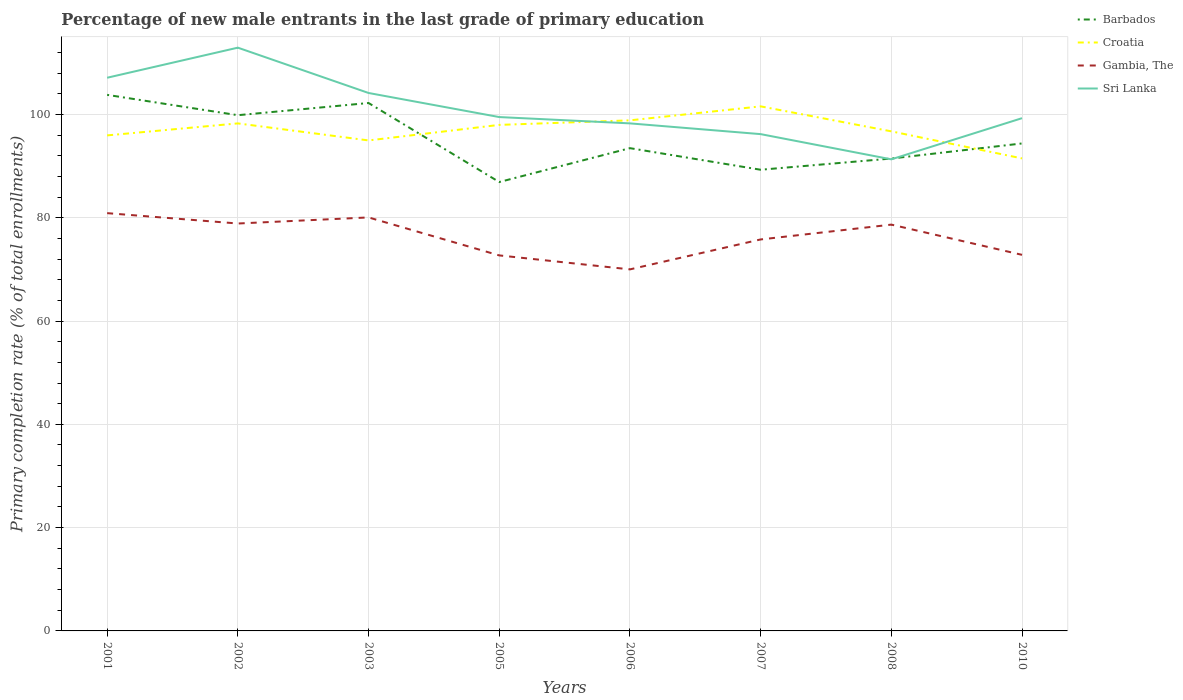How many different coloured lines are there?
Offer a very short reply. 4. Across all years, what is the maximum percentage of new male entrants in Gambia, The?
Your answer should be very brief. 70.01. What is the total percentage of new male entrants in Sri Lanka in the graph?
Provide a succinct answer. 8.18. What is the difference between the highest and the second highest percentage of new male entrants in Barbados?
Your answer should be very brief. 16.88. How many lines are there?
Ensure brevity in your answer.  4. How many years are there in the graph?
Provide a succinct answer. 8. What is the difference between two consecutive major ticks on the Y-axis?
Offer a terse response. 20. Does the graph contain any zero values?
Offer a terse response. No. Does the graph contain grids?
Offer a very short reply. Yes. How many legend labels are there?
Provide a succinct answer. 4. How are the legend labels stacked?
Offer a terse response. Vertical. What is the title of the graph?
Make the answer very short. Percentage of new male entrants in the last grade of primary education. What is the label or title of the Y-axis?
Your answer should be compact. Primary completion rate (% of total enrollments). What is the Primary completion rate (% of total enrollments) of Barbados in 2001?
Provide a short and direct response. 103.8. What is the Primary completion rate (% of total enrollments) of Croatia in 2001?
Your answer should be compact. 95.95. What is the Primary completion rate (% of total enrollments) of Gambia, The in 2001?
Give a very brief answer. 80.89. What is the Primary completion rate (% of total enrollments) in Sri Lanka in 2001?
Your answer should be very brief. 107.11. What is the Primary completion rate (% of total enrollments) in Barbados in 2002?
Give a very brief answer. 99.86. What is the Primary completion rate (% of total enrollments) in Croatia in 2002?
Provide a short and direct response. 98.27. What is the Primary completion rate (% of total enrollments) in Gambia, The in 2002?
Offer a very short reply. 78.89. What is the Primary completion rate (% of total enrollments) in Sri Lanka in 2002?
Offer a very short reply. 112.94. What is the Primary completion rate (% of total enrollments) of Barbados in 2003?
Ensure brevity in your answer.  102.22. What is the Primary completion rate (% of total enrollments) of Croatia in 2003?
Give a very brief answer. 94.97. What is the Primary completion rate (% of total enrollments) in Gambia, The in 2003?
Provide a short and direct response. 80.06. What is the Primary completion rate (% of total enrollments) of Sri Lanka in 2003?
Offer a terse response. 104.16. What is the Primary completion rate (% of total enrollments) in Barbados in 2005?
Make the answer very short. 86.92. What is the Primary completion rate (% of total enrollments) of Croatia in 2005?
Your answer should be compact. 97.98. What is the Primary completion rate (% of total enrollments) in Gambia, The in 2005?
Keep it short and to the point. 72.71. What is the Primary completion rate (% of total enrollments) in Sri Lanka in 2005?
Your answer should be very brief. 99.5. What is the Primary completion rate (% of total enrollments) in Barbados in 2006?
Your answer should be compact. 93.48. What is the Primary completion rate (% of total enrollments) of Croatia in 2006?
Provide a succinct answer. 98.86. What is the Primary completion rate (% of total enrollments) of Gambia, The in 2006?
Give a very brief answer. 70.01. What is the Primary completion rate (% of total enrollments) in Sri Lanka in 2006?
Make the answer very short. 98.27. What is the Primary completion rate (% of total enrollments) of Barbados in 2007?
Offer a terse response. 89.3. What is the Primary completion rate (% of total enrollments) of Croatia in 2007?
Your answer should be compact. 101.57. What is the Primary completion rate (% of total enrollments) of Gambia, The in 2007?
Your answer should be very brief. 75.8. What is the Primary completion rate (% of total enrollments) in Sri Lanka in 2007?
Give a very brief answer. 96.19. What is the Primary completion rate (% of total enrollments) of Barbados in 2008?
Offer a terse response. 91.47. What is the Primary completion rate (% of total enrollments) in Croatia in 2008?
Offer a very short reply. 96.73. What is the Primary completion rate (% of total enrollments) in Gambia, The in 2008?
Offer a terse response. 78.67. What is the Primary completion rate (% of total enrollments) of Sri Lanka in 2008?
Provide a short and direct response. 91.31. What is the Primary completion rate (% of total enrollments) in Barbados in 2010?
Make the answer very short. 94.39. What is the Primary completion rate (% of total enrollments) of Croatia in 2010?
Make the answer very short. 91.49. What is the Primary completion rate (% of total enrollments) in Gambia, The in 2010?
Give a very brief answer. 72.82. What is the Primary completion rate (% of total enrollments) in Sri Lanka in 2010?
Ensure brevity in your answer.  99.28. Across all years, what is the maximum Primary completion rate (% of total enrollments) of Barbados?
Provide a succinct answer. 103.8. Across all years, what is the maximum Primary completion rate (% of total enrollments) of Croatia?
Your answer should be very brief. 101.57. Across all years, what is the maximum Primary completion rate (% of total enrollments) of Gambia, The?
Keep it short and to the point. 80.89. Across all years, what is the maximum Primary completion rate (% of total enrollments) in Sri Lanka?
Offer a very short reply. 112.94. Across all years, what is the minimum Primary completion rate (% of total enrollments) of Barbados?
Provide a short and direct response. 86.92. Across all years, what is the minimum Primary completion rate (% of total enrollments) of Croatia?
Provide a succinct answer. 91.49. Across all years, what is the minimum Primary completion rate (% of total enrollments) of Gambia, The?
Provide a succinct answer. 70.01. Across all years, what is the minimum Primary completion rate (% of total enrollments) of Sri Lanka?
Give a very brief answer. 91.31. What is the total Primary completion rate (% of total enrollments) of Barbados in the graph?
Make the answer very short. 761.42. What is the total Primary completion rate (% of total enrollments) of Croatia in the graph?
Provide a short and direct response. 775.83. What is the total Primary completion rate (% of total enrollments) of Gambia, The in the graph?
Your answer should be compact. 609.85. What is the total Primary completion rate (% of total enrollments) in Sri Lanka in the graph?
Give a very brief answer. 808.77. What is the difference between the Primary completion rate (% of total enrollments) in Barbados in 2001 and that in 2002?
Provide a short and direct response. 3.94. What is the difference between the Primary completion rate (% of total enrollments) of Croatia in 2001 and that in 2002?
Provide a succinct answer. -2.32. What is the difference between the Primary completion rate (% of total enrollments) in Gambia, The in 2001 and that in 2002?
Your answer should be very brief. 2.01. What is the difference between the Primary completion rate (% of total enrollments) of Sri Lanka in 2001 and that in 2002?
Your answer should be very brief. -5.82. What is the difference between the Primary completion rate (% of total enrollments) of Barbados in 2001 and that in 2003?
Make the answer very short. 1.58. What is the difference between the Primary completion rate (% of total enrollments) in Croatia in 2001 and that in 2003?
Your response must be concise. 0.98. What is the difference between the Primary completion rate (% of total enrollments) of Gambia, The in 2001 and that in 2003?
Your response must be concise. 0.83. What is the difference between the Primary completion rate (% of total enrollments) in Sri Lanka in 2001 and that in 2003?
Keep it short and to the point. 2.95. What is the difference between the Primary completion rate (% of total enrollments) of Barbados in 2001 and that in 2005?
Make the answer very short. 16.88. What is the difference between the Primary completion rate (% of total enrollments) of Croatia in 2001 and that in 2005?
Your answer should be compact. -2.03. What is the difference between the Primary completion rate (% of total enrollments) in Gambia, The in 2001 and that in 2005?
Your answer should be very brief. 8.18. What is the difference between the Primary completion rate (% of total enrollments) of Sri Lanka in 2001 and that in 2005?
Make the answer very short. 7.61. What is the difference between the Primary completion rate (% of total enrollments) of Barbados in 2001 and that in 2006?
Your response must be concise. 10.32. What is the difference between the Primary completion rate (% of total enrollments) of Croatia in 2001 and that in 2006?
Offer a terse response. -2.92. What is the difference between the Primary completion rate (% of total enrollments) in Gambia, The in 2001 and that in 2006?
Give a very brief answer. 10.89. What is the difference between the Primary completion rate (% of total enrollments) in Sri Lanka in 2001 and that in 2006?
Provide a succinct answer. 8.84. What is the difference between the Primary completion rate (% of total enrollments) of Barbados in 2001 and that in 2007?
Provide a short and direct response. 14.5. What is the difference between the Primary completion rate (% of total enrollments) in Croatia in 2001 and that in 2007?
Your answer should be compact. -5.62. What is the difference between the Primary completion rate (% of total enrollments) of Gambia, The in 2001 and that in 2007?
Provide a succinct answer. 5.09. What is the difference between the Primary completion rate (% of total enrollments) in Sri Lanka in 2001 and that in 2007?
Ensure brevity in your answer.  10.92. What is the difference between the Primary completion rate (% of total enrollments) of Barbados in 2001 and that in 2008?
Give a very brief answer. 12.33. What is the difference between the Primary completion rate (% of total enrollments) of Croatia in 2001 and that in 2008?
Provide a short and direct response. -0.78. What is the difference between the Primary completion rate (% of total enrollments) of Gambia, The in 2001 and that in 2008?
Your response must be concise. 2.22. What is the difference between the Primary completion rate (% of total enrollments) of Sri Lanka in 2001 and that in 2008?
Your answer should be compact. 15.8. What is the difference between the Primary completion rate (% of total enrollments) in Barbados in 2001 and that in 2010?
Ensure brevity in your answer.  9.41. What is the difference between the Primary completion rate (% of total enrollments) of Croatia in 2001 and that in 2010?
Ensure brevity in your answer.  4.46. What is the difference between the Primary completion rate (% of total enrollments) in Gambia, The in 2001 and that in 2010?
Offer a terse response. 8.07. What is the difference between the Primary completion rate (% of total enrollments) of Sri Lanka in 2001 and that in 2010?
Ensure brevity in your answer.  7.83. What is the difference between the Primary completion rate (% of total enrollments) of Barbados in 2002 and that in 2003?
Keep it short and to the point. -2.36. What is the difference between the Primary completion rate (% of total enrollments) in Croatia in 2002 and that in 2003?
Your response must be concise. 3.3. What is the difference between the Primary completion rate (% of total enrollments) in Gambia, The in 2002 and that in 2003?
Your response must be concise. -1.18. What is the difference between the Primary completion rate (% of total enrollments) of Sri Lanka in 2002 and that in 2003?
Ensure brevity in your answer.  8.77. What is the difference between the Primary completion rate (% of total enrollments) of Barbados in 2002 and that in 2005?
Provide a short and direct response. 12.94. What is the difference between the Primary completion rate (% of total enrollments) in Croatia in 2002 and that in 2005?
Your answer should be very brief. 0.29. What is the difference between the Primary completion rate (% of total enrollments) in Gambia, The in 2002 and that in 2005?
Make the answer very short. 6.18. What is the difference between the Primary completion rate (% of total enrollments) in Sri Lanka in 2002 and that in 2005?
Make the answer very short. 13.44. What is the difference between the Primary completion rate (% of total enrollments) of Barbados in 2002 and that in 2006?
Offer a terse response. 6.38. What is the difference between the Primary completion rate (% of total enrollments) in Croatia in 2002 and that in 2006?
Your answer should be very brief. -0.59. What is the difference between the Primary completion rate (% of total enrollments) in Gambia, The in 2002 and that in 2006?
Your answer should be compact. 8.88. What is the difference between the Primary completion rate (% of total enrollments) in Sri Lanka in 2002 and that in 2006?
Keep it short and to the point. 14.66. What is the difference between the Primary completion rate (% of total enrollments) of Barbados in 2002 and that in 2007?
Give a very brief answer. 10.56. What is the difference between the Primary completion rate (% of total enrollments) of Croatia in 2002 and that in 2007?
Your answer should be very brief. -3.3. What is the difference between the Primary completion rate (% of total enrollments) in Gambia, The in 2002 and that in 2007?
Your answer should be compact. 3.09. What is the difference between the Primary completion rate (% of total enrollments) of Sri Lanka in 2002 and that in 2007?
Provide a short and direct response. 16.74. What is the difference between the Primary completion rate (% of total enrollments) in Barbados in 2002 and that in 2008?
Provide a succinct answer. 8.39. What is the difference between the Primary completion rate (% of total enrollments) of Croatia in 2002 and that in 2008?
Your answer should be compact. 1.54. What is the difference between the Primary completion rate (% of total enrollments) of Gambia, The in 2002 and that in 2008?
Your response must be concise. 0.22. What is the difference between the Primary completion rate (% of total enrollments) in Sri Lanka in 2002 and that in 2008?
Give a very brief answer. 21.62. What is the difference between the Primary completion rate (% of total enrollments) in Barbados in 2002 and that in 2010?
Provide a short and direct response. 5.47. What is the difference between the Primary completion rate (% of total enrollments) in Croatia in 2002 and that in 2010?
Ensure brevity in your answer.  6.78. What is the difference between the Primary completion rate (% of total enrollments) in Gambia, The in 2002 and that in 2010?
Ensure brevity in your answer.  6.07. What is the difference between the Primary completion rate (% of total enrollments) in Sri Lanka in 2002 and that in 2010?
Offer a terse response. 13.65. What is the difference between the Primary completion rate (% of total enrollments) of Barbados in 2003 and that in 2005?
Offer a terse response. 15.3. What is the difference between the Primary completion rate (% of total enrollments) in Croatia in 2003 and that in 2005?
Offer a terse response. -3.01. What is the difference between the Primary completion rate (% of total enrollments) in Gambia, The in 2003 and that in 2005?
Give a very brief answer. 7.35. What is the difference between the Primary completion rate (% of total enrollments) in Sri Lanka in 2003 and that in 2005?
Give a very brief answer. 4.66. What is the difference between the Primary completion rate (% of total enrollments) in Barbados in 2003 and that in 2006?
Offer a terse response. 8.74. What is the difference between the Primary completion rate (% of total enrollments) in Croatia in 2003 and that in 2006?
Your answer should be compact. -3.89. What is the difference between the Primary completion rate (% of total enrollments) of Gambia, The in 2003 and that in 2006?
Offer a very short reply. 10.06. What is the difference between the Primary completion rate (% of total enrollments) of Sri Lanka in 2003 and that in 2006?
Your answer should be compact. 5.89. What is the difference between the Primary completion rate (% of total enrollments) of Barbados in 2003 and that in 2007?
Offer a terse response. 12.92. What is the difference between the Primary completion rate (% of total enrollments) in Croatia in 2003 and that in 2007?
Provide a succinct answer. -6.6. What is the difference between the Primary completion rate (% of total enrollments) of Gambia, The in 2003 and that in 2007?
Offer a very short reply. 4.26. What is the difference between the Primary completion rate (% of total enrollments) in Sri Lanka in 2003 and that in 2007?
Make the answer very short. 7.97. What is the difference between the Primary completion rate (% of total enrollments) in Barbados in 2003 and that in 2008?
Offer a terse response. 10.75. What is the difference between the Primary completion rate (% of total enrollments) in Croatia in 2003 and that in 2008?
Your answer should be very brief. -1.76. What is the difference between the Primary completion rate (% of total enrollments) of Gambia, The in 2003 and that in 2008?
Your answer should be very brief. 1.39. What is the difference between the Primary completion rate (% of total enrollments) of Sri Lanka in 2003 and that in 2008?
Offer a very short reply. 12.85. What is the difference between the Primary completion rate (% of total enrollments) in Barbados in 2003 and that in 2010?
Keep it short and to the point. 7.83. What is the difference between the Primary completion rate (% of total enrollments) of Croatia in 2003 and that in 2010?
Offer a terse response. 3.48. What is the difference between the Primary completion rate (% of total enrollments) of Gambia, The in 2003 and that in 2010?
Make the answer very short. 7.24. What is the difference between the Primary completion rate (% of total enrollments) in Sri Lanka in 2003 and that in 2010?
Give a very brief answer. 4.88. What is the difference between the Primary completion rate (% of total enrollments) of Barbados in 2005 and that in 2006?
Offer a terse response. -6.56. What is the difference between the Primary completion rate (% of total enrollments) in Croatia in 2005 and that in 2006?
Provide a succinct answer. -0.88. What is the difference between the Primary completion rate (% of total enrollments) in Gambia, The in 2005 and that in 2006?
Ensure brevity in your answer.  2.71. What is the difference between the Primary completion rate (% of total enrollments) of Sri Lanka in 2005 and that in 2006?
Make the answer very short. 1.22. What is the difference between the Primary completion rate (% of total enrollments) of Barbados in 2005 and that in 2007?
Make the answer very short. -2.38. What is the difference between the Primary completion rate (% of total enrollments) of Croatia in 2005 and that in 2007?
Offer a terse response. -3.59. What is the difference between the Primary completion rate (% of total enrollments) in Gambia, The in 2005 and that in 2007?
Keep it short and to the point. -3.09. What is the difference between the Primary completion rate (% of total enrollments) in Sri Lanka in 2005 and that in 2007?
Provide a short and direct response. 3.3. What is the difference between the Primary completion rate (% of total enrollments) of Barbados in 2005 and that in 2008?
Your answer should be very brief. -4.55. What is the difference between the Primary completion rate (% of total enrollments) of Croatia in 2005 and that in 2008?
Offer a very short reply. 1.25. What is the difference between the Primary completion rate (% of total enrollments) of Gambia, The in 2005 and that in 2008?
Keep it short and to the point. -5.96. What is the difference between the Primary completion rate (% of total enrollments) of Sri Lanka in 2005 and that in 2008?
Offer a very short reply. 8.18. What is the difference between the Primary completion rate (% of total enrollments) of Barbados in 2005 and that in 2010?
Offer a very short reply. -7.47. What is the difference between the Primary completion rate (% of total enrollments) of Croatia in 2005 and that in 2010?
Your response must be concise. 6.49. What is the difference between the Primary completion rate (% of total enrollments) of Gambia, The in 2005 and that in 2010?
Give a very brief answer. -0.11. What is the difference between the Primary completion rate (% of total enrollments) in Sri Lanka in 2005 and that in 2010?
Your answer should be compact. 0.21. What is the difference between the Primary completion rate (% of total enrollments) of Barbados in 2006 and that in 2007?
Provide a short and direct response. 4.18. What is the difference between the Primary completion rate (% of total enrollments) in Croatia in 2006 and that in 2007?
Offer a terse response. -2.71. What is the difference between the Primary completion rate (% of total enrollments) of Gambia, The in 2006 and that in 2007?
Your response must be concise. -5.79. What is the difference between the Primary completion rate (% of total enrollments) of Sri Lanka in 2006 and that in 2007?
Your response must be concise. 2.08. What is the difference between the Primary completion rate (% of total enrollments) of Barbados in 2006 and that in 2008?
Your answer should be compact. 2.01. What is the difference between the Primary completion rate (% of total enrollments) of Croatia in 2006 and that in 2008?
Offer a very short reply. 2.13. What is the difference between the Primary completion rate (% of total enrollments) of Gambia, The in 2006 and that in 2008?
Keep it short and to the point. -8.67. What is the difference between the Primary completion rate (% of total enrollments) of Sri Lanka in 2006 and that in 2008?
Ensure brevity in your answer.  6.96. What is the difference between the Primary completion rate (% of total enrollments) in Barbados in 2006 and that in 2010?
Provide a short and direct response. -0.91. What is the difference between the Primary completion rate (% of total enrollments) in Croatia in 2006 and that in 2010?
Provide a succinct answer. 7.37. What is the difference between the Primary completion rate (% of total enrollments) of Gambia, The in 2006 and that in 2010?
Your response must be concise. -2.81. What is the difference between the Primary completion rate (% of total enrollments) of Sri Lanka in 2006 and that in 2010?
Offer a very short reply. -1.01. What is the difference between the Primary completion rate (% of total enrollments) in Barbados in 2007 and that in 2008?
Your answer should be compact. -2.17. What is the difference between the Primary completion rate (% of total enrollments) of Croatia in 2007 and that in 2008?
Provide a succinct answer. 4.84. What is the difference between the Primary completion rate (% of total enrollments) of Gambia, The in 2007 and that in 2008?
Offer a terse response. -2.87. What is the difference between the Primary completion rate (% of total enrollments) in Sri Lanka in 2007 and that in 2008?
Keep it short and to the point. 4.88. What is the difference between the Primary completion rate (% of total enrollments) of Barbados in 2007 and that in 2010?
Offer a very short reply. -5.09. What is the difference between the Primary completion rate (% of total enrollments) of Croatia in 2007 and that in 2010?
Your answer should be very brief. 10.08. What is the difference between the Primary completion rate (% of total enrollments) of Gambia, The in 2007 and that in 2010?
Keep it short and to the point. 2.98. What is the difference between the Primary completion rate (% of total enrollments) of Sri Lanka in 2007 and that in 2010?
Provide a short and direct response. -3.09. What is the difference between the Primary completion rate (% of total enrollments) in Barbados in 2008 and that in 2010?
Provide a succinct answer. -2.92. What is the difference between the Primary completion rate (% of total enrollments) in Croatia in 2008 and that in 2010?
Make the answer very short. 5.24. What is the difference between the Primary completion rate (% of total enrollments) of Gambia, The in 2008 and that in 2010?
Provide a succinct answer. 5.85. What is the difference between the Primary completion rate (% of total enrollments) in Sri Lanka in 2008 and that in 2010?
Your answer should be compact. -7.97. What is the difference between the Primary completion rate (% of total enrollments) of Barbados in 2001 and the Primary completion rate (% of total enrollments) of Croatia in 2002?
Offer a very short reply. 5.53. What is the difference between the Primary completion rate (% of total enrollments) in Barbados in 2001 and the Primary completion rate (% of total enrollments) in Gambia, The in 2002?
Your answer should be compact. 24.91. What is the difference between the Primary completion rate (% of total enrollments) of Barbados in 2001 and the Primary completion rate (% of total enrollments) of Sri Lanka in 2002?
Keep it short and to the point. -9.14. What is the difference between the Primary completion rate (% of total enrollments) in Croatia in 2001 and the Primary completion rate (% of total enrollments) in Gambia, The in 2002?
Keep it short and to the point. 17.06. What is the difference between the Primary completion rate (% of total enrollments) of Croatia in 2001 and the Primary completion rate (% of total enrollments) of Sri Lanka in 2002?
Your response must be concise. -16.99. What is the difference between the Primary completion rate (% of total enrollments) in Gambia, The in 2001 and the Primary completion rate (% of total enrollments) in Sri Lanka in 2002?
Your answer should be very brief. -32.04. What is the difference between the Primary completion rate (% of total enrollments) of Barbados in 2001 and the Primary completion rate (% of total enrollments) of Croatia in 2003?
Your answer should be compact. 8.82. What is the difference between the Primary completion rate (% of total enrollments) of Barbados in 2001 and the Primary completion rate (% of total enrollments) of Gambia, The in 2003?
Keep it short and to the point. 23.73. What is the difference between the Primary completion rate (% of total enrollments) of Barbados in 2001 and the Primary completion rate (% of total enrollments) of Sri Lanka in 2003?
Keep it short and to the point. -0.36. What is the difference between the Primary completion rate (% of total enrollments) of Croatia in 2001 and the Primary completion rate (% of total enrollments) of Gambia, The in 2003?
Offer a very short reply. 15.88. What is the difference between the Primary completion rate (% of total enrollments) of Croatia in 2001 and the Primary completion rate (% of total enrollments) of Sri Lanka in 2003?
Give a very brief answer. -8.21. What is the difference between the Primary completion rate (% of total enrollments) in Gambia, The in 2001 and the Primary completion rate (% of total enrollments) in Sri Lanka in 2003?
Your answer should be compact. -23.27. What is the difference between the Primary completion rate (% of total enrollments) in Barbados in 2001 and the Primary completion rate (% of total enrollments) in Croatia in 2005?
Your answer should be very brief. 5.81. What is the difference between the Primary completion rate (% of total enrollments) of Barbados in 2001 and the Primary completion rate (% of total enrollments) of Gambia, The in 2005?
Provide a succinct answer. 31.09. What is the difference between the Primary completion rate (% of total enrollments) in Barbados in 2001 and the Primary completion rate (% of total enrollments) in Sri Lanka in 2005?
Your response must be concise. 4.3. What is the difference between the Primary completion rate (% of total enrollments) of Croatia in 2001 and the Primary completion rate (% of total enrollments) of Gambia, The in 2005?
Give a very brief answer. 23.24. What is the difference between the Primary completion rate (% of total enrollments) of Croatia in 2001 and the Primary completion rate (% of total enrollments) of Sri Lanka in 2005?
Make the answer very short. -3.55. What is the difference between the Primary completion rate (% of total enrollments) of Gambia, The in 2001 and the Primary completion rate (% of total enrollments) of Sri Lanka in 2005?
Your answer should be compact. -18.6. What is the difference between the Primary completion rate (% of total enrollments) in Barbados in 2001 and the Primary completion rate (% of total enrollments) in Croatia in 2006?
Provide a short and direct response. 4.93. What is the difference between the Primary completion rate (% of total enrollments) of Barbados in 2001 and the Primary completion rate (% of total enrollments) of Gambia, The in 2006?
Your answer should be compact. 33.79. What is the difference between the Primary completion rate (% of total enrollments) in Barbados in 2001 and the Primary completion rate (% of total enrollments) in Sri Lanka in 2006?
Give a very brief answer. 5.52. What is the difference between the Primary completion rate (% of total enrollments) in Croatia in 2001 and the Primary completion rate (% of total enrollments) in Gambia, The in 2006?
Ensure brevity in your answer.  25.94. What is the difference between the Primary completion rate (% of total enrollments) in Croatia in 2001 and the Primary completion rate (% of total enrollments) in Sri Lanka in 2006?
Make the answer very short. -2.33. What is the difference between the Primary completion rate (% of total enrollments) in Gambia, The in 2001 and the Primary completion rate (% of total enrollments) in Sri Lanka in 2006?
Give a very brief answer. -17.38. What is the difference between the Primary completion rate (% of total enrollments) in Barbados in 2001 and the Primary completion rate (% of total enrollments) in Croatia in 2007?
Keep it short and to the point. 2.23. What is the difference between the Primary completion rate (% of total enrollments) in Barbados in 2001 and the Primary completion rate (% of total enrollments) in Gambia, The in 2007?
Make the answer very short. 28. What is the difference between the Primary completion rate (% of total enrollments) of Barbados in 2001 and the Primary completion rate (% of total enrollments) of Sri Lanka in 2007?
Keep it short and to the point. 7.6. What is the difference between the Primary completion rate (% of total enrollments) of Croatia in 2001 and the Primary completion rate (% of total enrollments) of Gambia, The in 2007?
Your response must be concise. 20.15. What is the difference between the Primary completion rate (% of total enrollments) in Croatia in 2001 and the Primary completion rate (% of total enrollments) in Sri Lanka in 2007?
Provide a succinct answer. -0.24. What is the difference between the Primary completion rate (% of total enrollments) of Gambia, The in 2001 and the Primary completion rate (% of total enrollments) of Sri Lanka in 2007?
Ensure brevity in your answer.  -15.3. What is the difference between the Primary completion rate (% of total enrollments) of Barbados in 2001 and the Primary completion rate (% of total enrollments) of Croatia in 2008?
Make the answer very short. 7.07. What is the difference between the Primary completion rate (% of total enrollments) in Barbados in 2001 and the Primary completion rate (% of total enrollments) in Gambia, The in 2008?
Your answer should be compact. 25.13. What is the difference between the Primary completion rate (% of total enrollments) of Barbados in 2001 and the Primary completion rate (% of total enrollments) of Sri Lanka in 2008?
Make the answer very short. 12.48. What is the difference between the Primary completion rate (% of total enrollments) in Croatia in 2001 and the Primary completion rate (% of total enrollments) in Gambia, The in 2008?
Provide a succinct answer. 17.28. What is the difference between the Primary completion rate (% of total enrollments) in Croatia in 2001 and the Primary completion rate (% of total enrollments) in Sri Lanka in 2008?
Your answer should be very brief. 4.64. What is the difference between the Primary completion rate (% of total enrollments) in Gambia, The in 2001 and the Primary completion rate (% of total enrollments) in Sri Lanka in 2008?
Offer a terse response. -10.42. What is the difference between the Primary completion rate (% of total enrollments) in Barbados in 2001 and the Primary completion rate (% of total enrollments) in Croatia in 2010?
Provide a short and direct response. 12.31. What is the difference between the Primary completion rate (% of total enrollments) of Barbados in 2001 and the Primary completion rate (% of total enrollments) of Gambia, The in 2010?
Your answer should be compact. 30.98. What is the difference between the Primary completion rate (% of total enrollments) of Barbados in 2001 and the Primary completion rate (% of total enrollments) of Sri Lanka in 2010?
Provide a short and direct response. 4.51. What is the difference between the Primary completion rate (% of total enrollments) in Croatia in 2001 and the Primary completion rate (% of total enrollments) in Gambia, The in 2010?
Keep it short and to the point. 23.13. What is the difference between the Primary completion rate (% of total enrollments) of Croatia in 2001 and the Primary completion rate (% of total enrollments) of Sri Lanka in 2010?
Your response must be concise. -3.34. What is the difference between the Primary completion rate (% of total enrollments) in Gambia, The in 2001 and the Primary completion rate (% of total enrollments) in Sri Lanka in 2010?
Offer a terse response. -18.39. What is the difference between the Primary completion rate (% of total enrollments) of Barbados in 2002 and the Primary completion rate (% of total enrollments) of Croatia in 2003?
Offer a terse response. 4.89. What is the difference between the Primary completion rate (% of total enrollments) in Barbados in 2002 and the Primary completion rate (% of total enrollments) in Gambia, The in 2003?
Keep it short and to the point. 19.79. What is the difference between the Primary completion rate (% of total enrollments) in Barbados in 2002 and the Primary completion rate (% of total enrollments) in Sri Lanka in 2003?
Offer a very short reply. -4.3. What is the difference between the Primary completion rate (% of total enrollments) in Croatia in 2002 and the Primary completion rate (% of total enrollments) in Gambia, The in 2003?
Offer a very short reply. 18.21. What is the difference between the Primary completion rate (% of total enrollments) in Croatia in 2002 and the Primary completion rate (% of total enrollments) in Sri Lanka in 2003?
Your response must be concise. -5.89. What is the difference between the Primary completion rate (% of total enrollments) of Gambia, The in 2002 and the Primary completion rate (% of total enrollments) of Sri Lanka in 2003?
Provide a succinct answer. -25.27. What is the difference between the Primary completion rate (% of total enrollments) in Barbados in 2002 and the Primary completion rate (% of total enrollments) in Croatia in 2005?
Give a very brief answer. 1.88. What is the difference between the Primary completion rate (% of total enrollments) of Barbados in 2002 and the Primary completion rate (% of total enrollments) of Gambia, The in 2005?
Your answer should be compact. 27.15. What is the difference between the Primary completion rate (% of total enrollments) of Barbados in 2002 and the Primary completion rate (% of total enrollments) of Sri Lanka in 2005?
Ensure brevity in your answer.  0.36. What is the difference between the Primary completion rate (% of total enrollments) of Croatia in 2002 and the Primary completion rate (% of total enrollments) of Gambia, The in 2005?
Give a very brief answer. 25.56. What is the difference between the Primary completion rate (% of total enrollments) of Croatia in 2002 and the Primary completion rate (% of total enrollments) of Sri Lanka in 2005?
Your answer should be compact. -1.23. What is the difference between the Primary completion rate (% of total enrollments) in Gambia, The in 2002 and the Primary completion rate (% of total enrollments) in Sri Lanka in 2005?
Keep it short and to the point. -20.61. What is the difference between the Primary completion rate (% of total enrollments) in Barbados in 2002 and the Primary completion rate (% of total enrollments) in Gambia, The in 2006?
Give a very brief answer. 29.85. What is the difference between the Primary completion rate (% of total enrollments) in Barbados in 2002 and the Primary completion rate (% of total enrollments) in Sri Lanka in 2006?
Your answer should be very brief. 1.58. What is the difference between the Primary completion rate (% of total enrollments) of Croatia in 2002 and the Primary completion rate (% of total enrollments) of Gambia, The in 2006?
Provide a short and direct response. 28.27. What is the difference between the Primary completion rate (% of total enrollments) of Croatia in 2002 and the Primary completion rate (% of total enrollments) of Sri Lanka in 2006?
Make the answer very short. -0. What is the difference between the Primary completion rate (% of total enrollments) in Gambia, The in 2002 and the Primary completion rate (% of total enrollments) in Sri Lanka in 2006?
Ensure brevity in your answer.  -19.39. What is the difference between the Primary completion rate (% of total enrollments) in Barbados in 2002 and the Primary completion rate (% of total enrollments) in Croatia in 2007?
Make the answer very short. -1.71. What is the difference between the Primary completion rate (% of total enrollments) of Barbados in 2002 and the Primary completion rate (% of total enrollments) of Gambia, The in 2007?
Your answer should be compact. 24.06. What is the difference between the Primary completion rate (% of total enrollments) of Barbados in 2002 and the Primary completion rate (% of total enrollments) of Sri Lanka in 2007?
Offer a very short reply. 3.67. What is the difference between the Primary completion rate (% of total enrollments) of Croatia in 2002 and the Primary completion rate (% of total enrollments) of Gambia, The in 2007?
Offer a very short reply. 22.47. What is the difference between the Primary completion rate (% of total enrollments) in Croatia in 2002 and the Primary completion rate (% of total enrollments) in Sri Lanka in 2007?
Your response must be concise. 2.08. What is the difference between the Primary completion rate (% of total enrollments) in Gambia, The in 2002 and the Primary completion rate (% of total enrollments) in Sri Lanka in 2007?
Provide a short and direct response. -17.31. What is the difference between the Primary completion rate (% of total enrollments) of Barbados in 2002 and the Primary completion rate (% of total enrollments) of Croatia in 2008?
Your answer should be compact. 3.13. What is the difference between the Primary completion rate (% of total enrollments) of Barbados in 2002 and the Primary completion rate (% of total enrollments) of Gambia, The in 2008?
Ensure brevity in your answer.  21.19. What is the difference between the Primary completion rate (% of total enrollments) of Barbados in 2002 and the Primary completion rate (% of total enrollments) of Sri Lanka in 2008?
Keep it short and to the point. 8.55. What is the difference between the Primary completion rate (% of total enrollments) of Croatia in 2002 and the Primary completion rate (% of total enrollments) of Gambia, The in 2008?
Your answer should be compact. 19.6. What is the difference between the Primary completion rate (% of total enrollments) of Croatia in 2002 and the Primary completion rate (% of total enrollments) of Sri Lanka in 2008?
Your answer should be very brief. 6.96. What is the difference between the Primary completion rate (% of total enrollments) in Gambia, The in 2002 and the Primary completion rate (% of total enrollments) in Sri Lanka in 2008?
Provide a short and direct response. -12.43. What is the difference between the Primary completion rate (% of total enrollments) in Barbados in 2002 and the Primary completion rate (% of total enrollments) in Croatia in 2010?
Offer a very short reply. 8.37. What is the difference between the Primary completion rate (% of total enrollments) of Barbados in 2002 and the Primary completion rate (% of total enrollments) of Gambia, The in 2010?
Provide a succinct answer. 27.04. What is the difference between the Primary completion rate (% of total enrollments) of Barbados in 2002 and the Primary completion rate (% of total enrollments) of Sri Lanka in 2010?
Offer a terse response. 0.57. What is the difference between the Primary completion rate (% of total enrollments) in Croatia in 2002 and the Primary completion rate (% of total enrollments) in Gambia, The in 2010?
Your answer should be very brief. 25.45. What is the difference between the Primary completion rate (% of total enrollments) in Croatia in 2002 and the Primary completion rate (% of total enrollments) in Sri Lanka in 2010?
Your answer should be compact. -1.01. What is the difference between the Primary completion rate (% of total enrollments) of Gambia, The in 2002 and the Primary completion rate (% of total enrollments) of Sri Lanka in 2010?
Provide a short and direct response. -20.4. What is the difference between the Primary completion rate (% of total enrollments) in Barbados in 2003 and the Primary completion rate (% of total enrollments) in Croatia in 2005?
Give a very brief answer. 4.24. What is the difference between the Primary completion rate (% of total enrollments) in Barbados in 2003 and the Primary completion rate (% of total enrollments) in Gambia, The in 2005?
Offer a very short reply. 29.51. What is the difference between the Primary completion rate (% of total enrollments) of Barbados in 2003 and the Primary completion rate (% of total enrollments) of Sri Lanka in 2005?
Give a very brief answer. 2.72. What is the difference between the Primary completion rate (% of total enrollments) in Croatia in 2003 and the Primary completion rate (% of total enrollments) in Gambia, The in 2005?
Offer a terse response. 22.26. What is the difference between the Primary completion rate (% of total enrollments) of Croatia in 2003 and the Primary completion rate (% of total enrollments) of Sri Lanka in 2005?
Offer a terse response. -4.52. What is the difference between the Primary completion rate (% of total enrollments) of Gambia, The in 2003 and the Primary completion rate (% of total enrollments) of Sri Lanka in 2005?
Keep it short and to the point. -19.43. What is the difference between the Primary completion rate (% of total enrollments) of Barbados in 2003 and the Primary completion rate (% of total enrollments) of Croatia in 2006?
Your response must be concise. 3.36. What is the difference between the Primary completion rate (% of total enrollments) in Barbados in 2003 and the Primary completion rate (% of total enrollments) in Gambia, The in 2006?
Offer a very short reply. 32.21. What is the difference between the Primary completion rate (% of total enrollments) in Barbados in 2003 and the Primary completion rate (% of total enrollments) in Sri Lanka in 2006?
Provide a succinct answer. 3.94. What is the difference between the Primary completion rate (% of total enrollments) of Croatia in 2003 and the Primary completion rate (% of total enrollments) of Gambia, The in 2006?
Your answer should be very brief. 24.97. What is the difference between the Primary completion rate (% of total enrollments) of Croatia in 2003 and the Primary completion rate (% of total enrollments) of Sri Lanka in 2006?
Provide a short and direct response. -3.3. What is the difference between the Primary completion rate (% of total enrollments) of Gambia, The in 2003 and the Primary completion rate (% of total enrollments) of Sri Lanka in 2006?
Provide a short and direct response. -18.21. What is the difference between the Primary completion rate (% of total enrollments) in Barbados in 2003 and the Primary completion rate (% of total enrollments) in Croatia in 2007?
Your answer should be very brief. 0.65. What is the difference between the Primary completion rate (% of total enrollments) of Barbados in 2003 and the Primary completion rate (% of total enrollments) of Gambia, The in 2007?
Your answer should be compact. 26.42. What is the difference between the Primary completion rate (% of total enrollments) of Barbados in 2003 and the Primary completion rate (% of total enrollments) of Sri Lanka in 2007?
Make the answer very short. 6.03. What is the difference between the Primary completion rate (% of total enrollments) of Croatia in 2003 and the Primary completion rate (% of total enrollments) of Gambia, The in 2007?
Offer a terse response. 19.17. What is the difference between the Primary completion rate (% of total enrollments) of Croatia in 2003 and the Primary completion rate (% of total enrollments) of Sri Lanka in 2007?
Give a very brief answer. -1.22. What is the difference between the Primary completion rate (% of total enrollments) of Gambia, The in 2003 and the Primary completion rate (% of total enrollments) of Sri Lanka in 2007?
Keep it short and to the point. -16.13. What is the difference between the Primary completion rate (% of total enrollments) of Barbados in 2003 and the Primary completion rate (% of total enrollments) of Croatia in 2008?
Ensure brevity in your answer.  5.49. What is the difference between the Primary completion rate (% of total enrollments) in Barbados in 2003 and the Primary completion rate (% of total enrollments) in Gambia, The in 2008?
Your answer should be very brief. 23.55. What is the difference between the Primary completion rate (% of total enrollments) of Barbados in 2003 and the Primary completion rate (% of total enrollments) of Sri Lanka in 2008?
Your response must be concise. 10.91. What is the difference between the Primary completion rate (% of total enrollments) in Croatia in 2003 and the Primary completion rate (% of total enrollments) in Gambia, The in 2008?
Your response must be concise. 16.3. What is the difference between the Primary completion rate (% of total enrollments) of Croatia in 2003 and the Primary completion rate (% of total enrollments) of Sri Lanka in 2008?
Your response must be concise. 3.66. What is the difference between the Primary completion rate (% of total enrollments) in Gambia, The in 2003 and the Primary completion rate (% of total enrollments) in Sri Lanka in 2008?
Provide a short and direct response. -11.25. What is the difference between the Primary completion rate (% of total enrollments) of Barbados in 2003 and the Primary completion rate (% of total enrollments) of Croatia in 2010?
Your response must be concise. 10.73. What is the difference between the Primary completion rate (% of total enrollments) of Barbados in 2003 and the Primary completion rate (% of total enrollments) of Gambia, The in 2010?
Your answer should be very brief. 29.4. What is the difference between the Primary completion rate (% of total enrollments) in Barbados in 2003 and the Primary completion rate (% of total enrollments) in Sri Lanka in 2010?
Offer a terse response. 2.94. What is the difference between the Primary completion rate (% of total enrollments) of Croatia in 2003 and the Primary completion rate (% of total enrollments) of Gambia, The in 2010?
Keep it short and to the point. 22.15. What is the difference between the Primary completion rate (% of total enrollments) of Croatia in 2003 and the Primary completion rate (% of total enrollments) of Sri Lanka in 2010?
Ensure brevity in your answer.  -4.31. What is the difference between the Primary completion rate (% of total enrollments) of Gambia, The in 2003 and the Primary completion rate (% of total enrollments) of Sri Lanka in 2010?
Your response must be concise. -19.22. What is the difference between the Primary completion rate (% of total enrollments) of Barbados in 2005 and the Primary completion rate (% of total enrollments) of Croatia in 2006?
Keep it short and to the point. -11.95. What is the difference between the Primary completion rate (% of total enrollments) of Barbados in 2005 and the Primary completion rate (% of total enrollments) of Gambia, The in 2006?
Provide a short and direct response. 16.91. What is the difference between the Primary completion rate (% of total enrollments) of Barbados in 2005 and the Primary completion rate (% of total enrollments) of Sri Lanka in 2006?
Ensure brevity in your answer.  -11.36. What is the difference between the Primary completion rate (% of total enrollments) of Croatia in 2005 and the Primary completion rate (% of total enrollments) of Gambia, The in 2006?
Keep it short and to the point. 27.98. What is the difference between the Primary completion rate (% of total enrollments) of Croatia in 2005 and the Primary completion rate (% of total enrollments) of Sri Lanka in 2006?
Your answer should be compact. -0.29. What is the difference between the Primary completion rate (% of total enrollments) of Gambia, The in 2005 and the Primary completion rate (% of total enrollments) of Sri Lanka in 2006?
Offer a very short reply. -25.56. What is the difference between the Primary completion rate (% of total enrollments) in Barbados in 2005 and the Primary completion rate (% of total enrollments) in Croatia in 2007?
Keep it short and to the point. -14.65. What is the difference between the Primary completion rate (% of total enrollments) in Barbados in 2005 and the Primary completion rate (% of total enrollments) in Gambia, The in 2007?
Offer a very short reply. 11.12. What is the difference between the Primary completion rate (% of total enrollments) in Barbados in 2005 and the Primary completion rate (% of total enrollments) in Sri Lanka in 2007?
Provide a succinct answer. -9.28. What is the difference between the Primary completion rate (% of total enrollments) of Croatia in 2005 and the Primary completion rate (% of total enrollments) of Gambia, The in 2007?
Your response must be concise. 22.18. What is the difference between the Primary completion rate (% of total enrollments) in Croatia in 2005 and the Primary completion rate (% of total enrollments) in Sri Lanka in 2007?
Offer a terse response. 1.79. What is the difference between the Primary completion rate (% of total enrollments) in Gambia, The in 2005 and the Primary completion rate (% of total enrollments) in Sri Lanka in 2007?
Provide a short and direct response. -23.48. What is the difference between the Primary completion rate (% of total enrollments) of Barbados in 2005 and the Primary completion rate (% of total enrollments) of Croatia in 2008?
Provide a succinct answer. -9.82. What is the difference between the Primary completion rate (% of total enrollments) in Barbados in 2005 and the Primary completion rate (% of total enrollments) in Gambia, The in 2008?
Offer a terse response. 8.24. What is the difference between the Primary completion rate (% of total enrollments) of Barbados in 2005 and the Primary completion rate (% of total enrollments) of Sri Lanka in 2008?
Provide a succinct answer. -4.4. What is the difference between the Primary completion rate (% of total enrollments) in Croatia in 2005 and the Primary completion rate (% of total enrollments) in Gambia, The in 2008?
Your response must be concise. 19.31. What is the difference between the Primary completion rate (% of total enrollments) in Croatia in 2005 and the Primary completion rate (% of total enrollments) in Sri Lanka in 2008?
Provide a short and direct response. 6.67. What is the difference between the Primary completion rate (% of total enrollments) in Gambia, The in 2005 and the Primary completion rate (% of total enrollments) in Sri Lanka in 2008?
Make the answer very short. -18.6. What is the difference between the Primary completion rate (% of total enrollments) of Barbados in 2005 and the Primary completion rate (% of total enrollments) of Croatia in 2010?
Your response must be concise. -4.57. What is the difference between the Primary completion rate (% of total enrollments) of Barbados in 2005 and the Primary completion rate (% of total enrollments) of Gambia, The in 2010?
Make the answer very short. 14.1. What is the difference between the Primary completion rate (% of total enrollments) of Barbados in 2005 and the Primary completion rate (% of total enrollments) of Sri Lanka in 2010?
Offer a very short reply. -12.37. What is the difference between the Primary completion rate (% of total enrollments) of Croatia in 2005 and the Primary completion rate (% of total enrollments) of Gambia, The in 2010?
Your answer should be very brief. 25.16. What is the difference between the Primary completion rate (% of total enrollments) in Croatia in 2005 and the Primary completion rate (% of total enrollments) in Sri Lanka in 2010?
Offer a very short reply. -1.3. What is the difference between the Primary completion rate (% of total enrollments) in Gambia, The in 2005 and the Primary completion rate (% of total enrollments) in Sri Lanka in 2010?
Offer a terse response. -26.57. What is the difference between the Primary completion rate (% of total enrollments) in Barbados in 2006 and the Primary completion rate (% of total enrollments) in Croatia in 2007?
Ensure brevity in your answer.  -8.09. What is the difference between the Primary completion rate (% of total enrollments) of Barbados in 2006 and the Primary completion rate (% of total enrollments) of Gambia, The in 2007?
Offer a very short reply. 17.68. What is the difference between the Primary completion rate (% of total enrollments) of Barbados in 2006 and the Primary completion rate (% of total enrollments) of Sri Lanka in 2007?
Provide a succinct answer. -2.72. What is the difference between the Primary completion rate (% of total enrollments) of Croatia in 2006 and the Primary completion rate (% of total enrollments) of Gambia, The in 2007?
Make the answer very short. 23.06. What is the difference between the Primary completion rate (% of total enrollments) in Croatia in 2006 and the Primary completion rate (% of total enrollments) in Sri Lanka in 2007?
Give a very brief answer. 2.67. What is the difference between the Primary completion rate (% of total enrollments) of Gambia, The in 2006 and the Primary completion rate (% of total enrollments) of Sri Lanka in 2007?
Make the answer very short. -26.19. What is the difference between the Primary completion rate (% of total enrollments) of Barbados in 2006 and the Primary completion rate (% of total enrollments) of Croatia in 2008?
Keep it short and to the point. -3.25. What is the difference between the Primary completion rate (% of total enrollments) in Barbados in 2006 and the Primary completion rate (% of total enrollments) in Gambia, The in 2008?
Make the answer very short. 14.8. What is the difference between the Primary completion rate (% of total enrollments) of Barbados in 2006 and the Primary completion rate (% of total enrollments) of Sri Lanka in 2008?
Your answer should be compact. 2.16. What is the difference between the Primary completion rate (% of total enrollments) of Croatia in 2006 and the Primary completion rate (% of total enrollments) of Gambia, The in 2008?
Offer a terse response. 20.19. What is the difference between the Primary completion rate (% of total enrollments) of Croatia in 2006 and the Primary completion rate (% of total enrollments) of Sri Lanka in 2008?
Offer a very short reply. 7.55. What is the difference between the Primary completion rate (% of total enrollments) in Gambia, The in 2006 and the Primary completion rate (% of total enrollments) in Sri Lanka in 2008?
Offer a terse response. -21.31. What is the difference between the Primary completion rate (% of total enrollments) of Barbados in 2006 and the Primary completion rate (% of total enrollments) of Croatia in 2010?
Ensure brevity in your answer.  1.99. What is the difference between the Primary completion rate (% of total enrollments) of Barbados in 2006 and the Primary completion rate (% of total enrollments) of Gambia, The in 2010?
Your answer should be compact. 20.66. What is the difference between the Primary completion rate (% of total enrollments) in Barbados in 2006 and the Primary completion rate (% of total enrollments) in Sri Lanka in 2010?
Ensure brevity in your answer.  -5.81. What is the difference between the Primary completion rate (% of total enrollments) of Croatia in 2006 and the Primary completion rate (% of total enrollments) of Gambia, The in 2010?
Give a very brief answer. 26.04. What is the difference between the Primary completion rate (% of total enrollments) of Croatia in 2006 and the Primary completion rate (% of total enrollments) of Sri Lanka in 2010?
Your answer should be very brief. -0.42. What is the difference between the Primary completion rate (% of total enrollments) of Gambia, The in 2006 and the Primary completion rate (% of total enrollments) of Sri Lanka in 2010?
Your answer should be compact. -29.28. What is the difference between the Primary completion rate (% of total enrollments) in Barbados in 2007 and the Primary completion rate (% of total enrollments) in Croatia in 2008?
Give a very brief answer. -7.43. What is the difference between the Primary completion rate (% of total enrollments) in Barbados in 2007 and the Primary completion rate (% of total enrollments) in Gambia, The in 2008?
Offer a very short reply. 10.62. What is the difference between the Primary completion rate (% of total enrollments) in Barbados in 2007 and the Primary completion rate (% of total enrollments) in Sri Lanka in 2008?
Your answer should be compact. -2.02. What is the difference between the Primary completion rate (% of total enrollments) in Croatia in 2007 and the Primary completion rate (% of total enrollments) in Gambia, The in 2008?
Offer a terse response. 22.9. What is the difference between the Primary completion rate (% of total enrollments) in Croatia in 2007 and the Primary completion rate (% of total enrollments) in Sri Lanka in 2008?
Your answer should be very brief. 10.26. What is the difference between the Primary completion rate (% of total enrollments) in Gambia, The in 2007 and the Primary completion rate (% of total enrollments) in Sri Lanka in 2008?
Give a very brief answer. -15.51. What is the difference between the Primary completion rate (% of total enrollments) in Barbados in 2007 and the Primary completion rate (% of total enrollments) in Croatia in 2010?
Your answer should be compact. -2.19. What is the difference between the Primary completion rate (% of total enrollments) of Barbados in 2007 and the Primary completion rate (% of total enrollments) of Gambia, The in 2010?
Ensure brevity in your answer.  16.48. What is the difference between the Primary completion rate (% of total enrollments) of Barbados in 2007 and the Primary completion rate (% of total enrollments) of Sri Lanka in 2010?
Ensure brevity in your answer.  -9.99. What is the difference between the Primary completion rate (% of total enrollments) of Croatia in 2007 and the Primary completion rate (% of total enrollments) of Gambia, The in 2010?
Ensure brevity in your answer.  28.75. What is the difference between the Primary completion rate (% of total enrollments) in Croatia in 2007 and the Primary completion rate (% of total enrollments) in Sri Lanka in 2010?
Offer a terse response. 2.29. What is the difference between the Primary completion rate (% of total enrollments) in Gambia, The in 2007 and the Primary completion rate (% of total enrollments) in Sri Lanka in 2010?
Offer a very short reply. -23.48. What is the difference between the Primary completion rate (% of total enrollments) of Barbados in 2008 and the Primary completion rate (% of total enrollments) of Croatia in 2010?
Offer a terse response. -0.02. What is the difference between the Primary completion rate (% of total enrollments) of Barbados in 2008 and the Primary completion rate (% of total enrollments) of Gambia, The in 2010?
Offer a terse response. 18.65. What is the difference between the Primary completion rate (% of total enrollments) in Barbados in 2008 and the Primary completion rate (% of total enrollments) in Sri Lanka in 2010?
Offer a terse response. -7.81. What is the difference between the Primary completion rate (% of total enrollments) of Croatia in 2008 and the Primary completion rate (% of total enrollments) of Gambia, The in 2010?
Ensure brevity in your answer.  23.91. What is the difference between the Primary completion rate (% of total enrollments) in Croatia in 2008 and the Primary completion rate (% of total enrollments) in Sri Lanka in 2010?
Offer a terse response. -2.55. What is the difference between the Primary completion rate (% of total enrollments) of Gambia, The in 2008 and the Primary completion rate (% of total enrollments) of Sri Lanka in 2010?
Give a very brief answer. -20.61. What is the average Primary completion rate (% of total enrollments) of Barbados per year?
Offer a terse response. 95.18. What is the average Primary completion rate (% of total enrollments) of Croatia per year?
Ensure brevity in your answer.  96.98. What is the average Primary completion rate (% of total enrollments) in Gambia, The per year?
Offer a terse response. 76.23. What is the average Primary completion rate (% of total enrollments) in Sri Lanka per year?
Provide a succinct answer. 101.1. In the year 2001, what is the difference between the Primary completion rate (% of total enrollments) in Barbados and Primary completion rate (% of total enrollments) in Croatia?
Make the answer very short. 7.85. In the year 2001, what is the difference between the Primary completion rate (% of total enrollments) of Barbados and Primary completion rate (% of total enrollments) of Gambia, The?
Offer a very short reply. 22.9. In the year 2001, what is the difference between the Primary completion rate (% of total enrollments) in Barbados and Primary completion rate (% of total enrollments) in Sri Lanka?
Make the answer very short. -3.31. In the year 2001, what is the difference between the Primary completion rate (% of total enrollments) of Croatia and Primary completion rate (% of total enrollments) of Gambia, The?
Offer a terse response. 15.05. In the year 2001, what is the difference between the Primary completion rate (% of total enrollments) in Croatia and Primary completion rate (% of total enrollments) in Sri Lanka?
Your response must be concise. -11.16. In the year 2001, what is the difference between the Primary completion rate (% of total enrollments) of Gambia, The and Primary completion rate (% of total enrollments) of Sri Lanka?
Make the answer very short. -26.22. In the year 2002, what is the difference between the Primary completion rate (% of total enrollments) in Barbados and Primary completion rate (% of total enrollments) in Croatia?
Your response must be concise. 1.59. In the year 2002, what is the difference between the Primary completion rate (% of total enrollments) of Barbados and Primary completion rate (% of total enrollments) of Gambia, The?
Provide a succinct answer. 20.97. In the year 2002, what is the difference between the Primary completion rate (% of total enrollments) in Barbados and Primary completion rate (% of total enrollments) in Sri Lanka?
Provide a short and direct response. -13.08. In the year 2002, what is the difference between the Primary completion rate (% of total enrollments) of Croatia and Primary completion rate (% of total enrollments) of Gambia, The?
Offer a terse response. 19.38. In the year 2002, what is the difference between the Primary completion rate (% of total enrollments) of Croatia and Primary completion rate (% of total enrollments) of Sri Lanka?
Keep it short and to the point. -14.66. In the year 2002, what is the difference between the Primary completion rate (% of total enrollments) in Gambia, The and Primary completion rate (% of total enrollments) in Sri Lanka?
Give a very brief answer. -34.05. In the year 2003, what is the difference between the Primary completion rate (% of total enrollments) in Barbados and Primary completion rate (% of total enrollments) in Croatia?
Your answer should be compact. 7.25. In the year 2003, what is the difference between the Primary completion rate (% of total enrollments) of Barbados and Primary completion rate (% of total enrollments) of Gambia, The?
Make the answer very short. 22.16. In the year 2003, what is the difference between the Primary completion rate (% of total enrollments) in Barbados and Primary completion rate (% of total enrollments) in Sri Lanka?
Provide a short and direct response. -1.94. In the year 2003, what is the difference between the Primary completion rate (% of total enrollments) in Croatia and Primary completion rate (% of total enrollments) in Gambia, The?
Provide a short and direct response. 14.91. In the year 2003, what is the difference between the Primary completion rate (% of total enrollments) of Croatia and Primary completion rate (% of total enrollments) of Sri Lanka?
Your answer should be compact. -9.19. In the year 2003, what is the difference between the Primary completion rate (% of total enrollments) of Gambia, The and Primary completion rate (% of total enrollments) of Sri Lanka?
Make the answer very short. -24.1. In the year 2005, what is the difference between the Primary completion rate (% of total enrollments) in Barbados and Primary completion rate (% of total enrollments) in Croatia?
Your answer should be compact. -11.07. In the year 2005, what is the difference between the Primary completion rate (% of total enrollments) in Barbados and Primary completion rate (% of total enrollments) in Gambia, The?
Offer a terse response. 14.2. In the year 2005, what is the difference between the Primary completion rate (% of total enrollments) in Barbados and Primary completion rate (% of total enrollments) in Sri Lanka?
Provide a succinct answer. -12.58. In the year 2005, what is the difference between the Primary completion rate (% of total enrollments) of Croatia and Primary completion rate (% of total enrollments) of Gambia, The?
Make the answer very short. 25.27. In the year 2005, what is the difference between the Primary completion rate (% of total enrollments) in Croatia and Primary completion rate (% of total enrollments) in Sri Lanka?
Provide a short and direct response. -1.51. In the year 2005, what is the difference between the Primary completion rate (% of total enrollments) of Gambia, The and Primary completion rate (% of total enrollments) of Sri Lanka?
Your answer should be compact. -26.79. In the year 2006, what is the difference between the Primary completion rate (% of total enrollments) in Barbados and Primary completion rate (% of total enrollments) in Croatia?
Offer a very short reply. -5.39. In the year 2006, what is the difference between the Primary completion rate (% of total enrollments) of Barbados and Primary completion rate (% of total enrollments) of Gambia, The?
Provide a short and direct response. 23.47. In the year 2006, what is the difference between the Primary completion rate (% of total enrollments) of Barbados and Primary completion rate (% of total enrollments) of Sri Lanka?
Offer a very short reply. -4.8. In the year 2006, what is the difference between the Primary completion rate (% of total enrollments) of Croatia and Primary completion rate (% of total enrollments) of Gambia, The?
Provide a succinct answer. 28.86. In the year 2006, what is the difference between the Primary completion rate (% of total enrollments) of Croatia and Primary completion rate (% of total enrollments) of Sri Lanka?
Provide a succinct answer. 0.59. In the year 2006, what is the difference between the Primary completion rate (% of total enrollments) of Gambia, The and Primary completion rate (% of total enrollments) of Sri Lanka?
Give a very brief answer. -28.27. In the year 2007, what is the difference between the Primary completion rate (% of total enrollments) of Barbados and Primary completion rate (% of total enrollments) of Croatia?
Offer a terse response. -12.27. In the year 2007, what is the difference between the Primary completion rate (% of total enrollments) in Barbados and Primary completion rate (% of total enrollments) in Gambia, The?
Ensure brevity in your answer.  13.5. In the year 2007, what is the difference between the Primary completion rate (% of total enrollments) of Barbados and Primary completion rate (% of total enrollments) of Sri Lanka?
Keep it short and to the point. -6.9. In the year 2007, what is the difference between the Primary completion rate (% of total enrollments) of Croatia and Primary completion rate (% of total enrollments) of Gambia, The?
Your response must be concise. 25.77. In the year 2007, what is the difference between the Primary completion rate (% of total enrollments) of Croatia and Primary completion rate (% of total enrollments) of Sri Lanka?
Make the answer very short. 5.38. In the year 2007, what is the difference between the Primary completion rate (% of total enrollments) in Gambia, The and Primary completion rate (% of total enrollments) in Sri Lanka?
Make the answer very short. -20.39. In the year 2008, what is the difference between the Primary completion rate (% of total enrollments) in Barbados and Primary completion rate (% of total enrollments) in Croatia?
Your answer should be very brief. -5.26. In the year 2008, what is the difference between the Primary completion rate (% of total enrollments) of Barbados and Primary completion rate (% of total enrollments) of Gambia, The?
Keep it short and to the point. 12.8. In the year 2008, what is the difference between the Primary completion rate (% of total enrollments) of Barbados and Primary completion rate (% of total enrollments) of Sri Lanka?
Make the answer very short. 0.16. In the year 2008, what is the difference between the Primary completion rate (% of total enrollments) of Croatia and Primary completion rate (% of total enrollments) of Gambia, The?
Your answer should be very brief. 18.06. In the year 2008, what is the difference between the Primary completion rate (% of total enrollments) of Croatia and Primary completion rate (% of total enrollments) of Sri Lanka?
Offer a very short reply. 5.42. In the year 2008, what is the difference between the Primary completion rate (% of total enrollments) in Gambia, The and Primary completion rate (% of total enrollments) in Sri Lanka?
Provide a short and direct response. -12.64. In the year 2010, what is the difference between the Primary completion rate (% of total enrollments) in Barbados and Primary completion rate (% of total enrollments) in Croatia?
Give a very brief answer. 2.9. In the year 2010, what is the difference between the Primary completion rate (% of total enrollments) in Barbados and Primary completion rate (% of total enrollments) in Gambia, The?
Your answer should be very brief. 21.57. In the year 2010, what is the difference between the Primary completion rate (% of total enrollments) of Barbados and Primary completion rate (% of total enrollments) of Sri Lanka?
Offer a very short reply. -4.89. In the year 2010, what is the difference between the Primary completion rate (% of total enrollments) in Croatia and Primary completion rate (% of total enrollments) in Gambia, The?
Keep it short and to the point. 18.67. In the year 2010, what is the difference between the Primary completion rate (% of total enrollments) in Croatia and Primary completion rate (% of total enrollments) in Sri Lanka?
Offer a very short reply. -7.79. In the year 2010, what is the difference between the Primary completion rate (% of total enrollments) in Gambia, The and Primary completion rate (% of total enrollments) in Sri Lanka?
Provide a succinct answer. -26.46. What is the ratio of the Primary completion rate (% of total enrollments) in Barbados in 2001 to that in 2002?
Your answer should be compact. 1.04. What is the ratio of the Primary completion rate (% of total enrollments) of Croatia in 2001 to that in 2002?
Your answer should be compact. 0.98. What is the ratio of the Primary completion rate (% of total enrollments) in Gambia, The in 2001 to that in 2002?
Make the answer very short. 1.03. What is the ratio of the Primary completion rate (% of total enrollments) of Sri Lanka in 2001 to that in 2002?
Your answer should be very brief. 0.95. What is the ratio of the Primary completion rate (% of total enrollments) in Barbados in 2001 to that in 2003?
Ensure brevity in your answer.  1.02. What is the ratio of the Primary completion rate (% of total enrollments) in Croatia in 2001 to that in 2003?
Your answer should be very brief. 1.01. What is the ratio of the Primary completion rate (% of total enrollments) in Gambia, The in 2001 to that in 2003?
Your response must be concise. 1.01. What is the ratio of the Primary completion rate (% of total enrollments) in Sri Lanka in 2001 to that in 2003?
Your response must be concise. 1.03. What is the ratio of the Primary completion rate (% of total enrollments) of Barbados in 2001 to that in 2005?
Provide a succinct answer. 1.19. What is the ratio of the Primary completion rate (% of total enrollments) of Croatia in 2001 to that in 2005?
Make the answer very short. 0.98. What is the ratio of the Primary completion rate (% of total enrollments) in Gambia, The in 2001 to that in 2005?
Give a very brief answer. 1.11. What is the ratio of the Primary completion rate (% of total enrollments) of Sri Lanka in 2001 to that in 2005?
Provide a succinct answer. 1.08. What is the ratio of the Primary completion rate (% of total enrollments) in Barbados in 2001 to that in 2006?
Make the answer very short. 1.11. What is the ratio of the Primary completion rate (% of total enrollments) of Croatia in 2001 to that in 2006?
Give a very brief answer. 0.97. What is the ratio of the Primary completion rate (% of total enrollments) of Gambia, The in 2001 to that in 2006?
Offer a terse response. 1.16. What is the ratio of the Primary completion rate (% of total enrollments) of Sri Lanka in 2001 to that in 2006?
Make the answer very short. 1.09. What is the ratio of the Primary completion rate (% of total enrollments) in Barbados in 2001 to that in 2007?
Your answer should be very brief. 1.16. What is the ratio of the Primary completion rate (% of total enrollments) in Croatia in 2001 to that in 2007?
Your answer should be very brief. 0.94. What is the ratio of the Primary completion rate (% of total enrollments) of Gambia, The in 2001 to that in 2007?
Your answer should be compact. 1.07. What is the ratio of the Primary completion rate (% of total enrollments) of Sri Lanka in 2001 to that in 2007?
Provide a succinct answer. 1.11. What is the ratio of the Primary completion rate (% of total enrollments) of Barbados in 2001 to that in 2008?
Offer a terse response. 1.13. What is the ratio of the Primary completion rate (% of total enrollments) of Croatia in 2001 to that in 2008?
Keep it short and to the point. 0.99. What is the ratio of the Primary completion rate (% of total enrollments) of Gambia, The in 2001 to that in 2008?
Offer a very short reply. 1.03. What is the ratio of the Primary completion rate (% of total enrollments) of Sri Lanka in 2001 to that in 2008?
Keep it short and to the point. 1.17. What is the ratio of the Primary completion rate (% of total enrollments) in Barbados in 2001 to that in 2010?
Offer a terse response. 1.1. What is the ratio of the Primary completion rate (% of total enrollments) in Croatia in 2001 to that in 2010?
Your response must be concise. 1.05. What is the ratio of the Primary completion rate (% of total enrollments) in Gambia, The in 2001 to that in 2010?
Your answer should be very brief. 1.11. What is the ratio of the Primary completion rate (% of total enrollments) in Sri Lanka in 2001 to that in 2010?
Keep it short and to the point. 1.08. What is the ratio of the Primary completion rate (% of total enrollments) of Barbados in 2002 to that in 2003?
Ensure brevity in your answer.  0.98. What is the ratio of the Primary completion rate (% of total enrollments) in Croatia in 2002 to that in 2003?
Keep it short and to the point. 1.03. What is the ratio of the Primary completion rate (% of total enrollments) in Sri Lanka in 2002 to that in 2003?
Your answer should be very brief. 1.08. What is the ratio of the Primary completion rate (% of total enrollments) in Barbados in 2002 to that in 2005?
Ensure brevity in your answer.  1.15. What is the ratio of the Primary completion rate (% of total enrollments) in Croatia in 2002 to that in 2005?
Your answer should be very brief. 1. What is the ratio of the Primary completion rate (% of total enrollments) in Gambia, The in 2002 to that in 2005?
Your response must be concise. 1.08. What is the ratio of the Primary completion rate (% of total enrollments) in Sri Lanka in 2002 to that in 2005?
Provide a succinct answer. 1.14. What is the ratio of the Primary completion rate (% of total enrollments) in Barbados in 2002 to that in 2006?
Your answer should be compact. 1.07. What is the ratio of the Primary completion rate (% of total enrollments) in Croatia in 2002 to that in 2006?
Give a very brief answer. 0.99. What is the ratio of the Primary completion rate (% of total enrollments) of Gambia, The in 2002 to that in 2006?
Your answer should be very brief. 1.13. What is the ratio of the Primary completion rate (% of total enrollments) of Sri Lanka in 2002 to that in 2006?
Provide a short and direct response. 1.15. What is the ratio of the Primary completion rate (% of total enrollments) in Barbados in 2002 to that in 2007?
Ensure brevity in your answer.  1.12. What is the ratio of the Primary completion rate (% of total enrollments) of Croatia in 2002 to that in 2007?
Make the answer very short. 0.97. What is the ratio of the Primary completion rate (% of total enrollments) of Gambia, The in 2002 to that in 2007?
Offer a very short reply. 1.04. What is the ratio of the Primary completion rate (% of total enrollments) of Sri Lanka in 2002 to that in 2007?
Your response must be concise. 1.17. What is the ratio of the Primary completion rate (% of total enrollments) of Barbados in 2002 to that in 2008?
Make the answer very short. 1.09. What is the ratio of the Primary completion rate (% of total enrollments) of Croatia in 2002 to that in 2008?
Your response must be concise. 1.02. What is the ratio of the Primary completion rate (% of total enrollments) in Gambia, The in 2002 to that in 2008?
Ensure brevity in your answer.  1. What is the ratio of the Primary completion rate (% of total enrollments) in Sri Lanka in 2002 to that in 2008?
Your answer should be compact. 1.24. What is the ratio of the Primary completion rate (% of total enrollments) in Barbados in 2002 to that in 2010?
Ensure brevity in your answer.  1.06. What is the ratio of the Primary completion rate (% of total enrollments) of Croatia in 2002 to that in 2010?
Your answer should be very brief. 1.07. What is the ratio of the Primary completion rate (% of total enrollments) in Gambia, The in 2002 to that in 2010?
Give a very brief answer. 1.08. What is the ratio of the Primary completion rate (% of total enrollments) in Sri Lanka in 2002 to that in 2010?
Offer a very short reply. 1.14. What is the ratio of the Primary completion rate (% of total enrollments) in Barbados in 2003 to that in 2005?
Offer a terse response. 1.18. What is the ratio of the Primary completion rate (% of total enrollments) in Croatia in 2003 to that in 2005?
Your answer should be very brief. 0.97. What is the ratio of the Primary completion rate (% of total enrollments) of Gambia, The in 2003 to that in 2005?
Your answer should be compact. 1.1. What is the ratio of the Primary completion rate (% of total enrollments) in Sri Lanka in 2003 to that in 2005?
Make the answer very short. 1.05. What is the ratio of the Primary completion rate (% of total enrollments) of Barbados in 2003 to that in 2006?
Your answer should be compact. 1.09. What is the ratio of the Primary completion rate (% of total enrollments) in Croatia in 2003 to that in 2006?
Your answer should be compact. 0.96. What is the ratio of the Primary completion rate (% of total enrollments) in Gambia, The in 2003 to that in 2006?
Ensure brevity in your answer.  1.14. What is the ratio of the Primary completion rate (% of total enrollments) in Sri Lanka in 2003 to that in 2006?
Offer a terse response. 1.06. What is the ratio of the Primary completion rate (% of total enrollments) in Barbados in 2003 to that in 2007?
Your answer should be compact. 1.14. What is the ratio of the Primary completion rate (% of total enrollments) of Croatia in 2003 to that in 2007?
Your answer should be very brief. 0.94. What is the ratio of the Primary completion rate (% of total enrollments) in Gambia, The in 2003 to that in 2007?
Your response must be concise. 1.06. What is the ratio of the Primary completion rate (% of total enrollments) in Sri Lanka in 2003 to that in 2007?
Ensure brevity in your answer.  1.08. What is the ratio of the Primary completion rate (% of total enrollments) in Barbados in 2003 to that in 2008?
Provide a short and direct response. 1.12. What is the ratio of the Primary completion rate (% of total enrollments) of Croatia in 2003 to that in 2008?
Provide a succinct answer. 0.98. What is the ratio of the Primary completion rate (% of total enrollments) of Gambia, The in 2003 to that in 2008?
Ensure brevity in your answer.  1.02. What is the ratio of the Primary completion rate (% of total enrollments) of Sri Lanka in 2003 to that in 2008?
Keep it short and to the point. 1.14. What is the ratio of the Primary completion rate (% of total enrollments) of Barbados in 2003 to that in 2010?
Give a very brief answer. 1.08. What is the ratio of the Primary completion rate (% of total enrollments) in Croatia in 2003 to that in 2010?
Offer a terse response. 1.04. What is the ratio of the Primary completion rate (% of total enrollments) of Gambia, The in 2003 to that in 2010?
Provide a short and direct response. 1.1. What is the ratio of the Primary completion rate (% of total enrollments) of Sri Lanka in 2003 to that in 2010?
Make the answer very short. 1.05. What is the ratio of the Primary completion rate (% of total enrollments) of Barbados in 2005 to that in 2006?
Provide a short and direct response. 0.93. What is the ratio of the Primary completion rate (% of total enrollments) of Gambia, The in 2005 to that in 2006?
Provide a short and direct response. 1.04. What is the ratio of the Primary completion rate (% of total enrollments) in Sri Lanka in 2005 to that in 2006?
Make the answer very short. 1.01. What is the ratio of the Primary completion rate (% of total enrollments) of Barbados in 2005 to that in 2007?
Give a very brief answer. 0.97. What is the ratio of the Primary completion rate (% of total enrollments) of Croatia in 2005 to that in 2007?
Your response must be concise. 0.96. What is the ratio of the Primary completion rate (% of total enrollments) in Gambia, The in 2005 to that in 2007?
Give a very brief answer. 0.96. What is the ratio of the Primary completion rate (% of total enrollments) of Sri Lanka in 2005 to that in 2007?
Offer a terse response. 1.03. What is the ratio of the Primary completion rate (% of total enrollments) in Barbados in 2005 to that in 2008?
Offer a very short reply. 0.95. What is the ratio of the Primary completion rate (% of total enrollments) in Croatia in 2005 to that in 2008?
Ensure brevity in your answer.  1.01. What is the ratio of the Primary completion rate (% of total enrollments) in Gambia, The in 2005 to that in 2008?
Provide a short and direct response. 0.92. What is the ratio of the Primary completion rate (% of total enrollments) of Sri Lanka in 2005 to that in 2008?
Ensure brevity in your answer.  1.09. What is the ratio of the Primary completion rate (% of total enrollments) of Barbados in 2005 to that in 2010?
Give a very brief answer. 0.92. What is the ratio of the Primary completion rate (% of total enrollments) of Croatia in 2005 to that in 2010?
Give a very brief answer. 1.07. What is the ratio of the Primary completion rate (% of total enrollments) in Gambia, The in 2005 to that in 2010?
Your answer should be very brief. 1. What is the ratio of the Primary completion rate (% of total enrollments) of Barbados in 2006 to that in 2007?
Keep it short and to the point. 1.05. What is the ratio of the Primary completion rate (% of total enrollments) in Croatia in 2006 to that in 2007?
Provide a short and direct response. 0.97. What is the ratio of the Primary completion rate (% of total enrollments) of Gambia, The in 2006 to that in 2007?
Provide a short and direct response. 0.92. What is the ratio of the Primary completion rate (% of total enrollments) in Sri Lanka in 2006 to that in 2007?
Your answer should be very brief. 1.02. What is the ratio of the Primary completion rate (% of total enrollments) of Barbados in 2006 to that in 2008?
Make the answer very short. 1.02. What is the ratio of the Primary completion rate (% of total enrollments) in Croatia in 2006 to that in 2008?
Provide a succinct answer. 1.02. What is the ratio of the Primary completion rate (% of total enrollments) in Gambia, The in 2006 to that in 2008?
Ensure brevity in your answer.  0.89. What is the ratio of the Primary completion rate (% of total enrollments) in Sri Lanka in 2006 to that in 2008?
Your answer should be compact. 1.08. What is the ratio of the Primary completion rate (% of total enrollments) in Barbados in 2006 to that in 2010?
Provide a succinct answer. 0.99. What is the ratio of the Primary completion rate (% of total enrollments) of Croatia in 2006 to that in 2010?
Your answer should be compact. 1.08. What is the ratio of the Primary completion rate (% of total enrollments) of Gambia, The in 2006 to that in 2010?
Make the answer very short. 0.96. What is the ratio of the Primary completion rate (% of total enrollments) in Barbados in 2007 to that in 2008?
Provide a short and direct response. 0.98. What is the ratio of the Primary completion rate (% of total enrollments) of Gambia, The in 2007 to that in 2008?
Provide a succinct answer. 0.96. What is the ratio of the Primary completion rate (% of total enrollments) of Sri Lanka in 2007 to that in 2008?
Offer a very short reply. 1.05. What is the ratio of the Primary completion rate (% of total enrollments) in Barbados in 2007 to that in 2010?
Your answer should be compact. 0.95. What is the ratio of the Primary completion rate (% of total enrollments) in Croatia in 2007 to that in 2010?
Give a very brief answer. 1.11. What is the ratio of the Primary completion rate (% of total enrollments) in Gambia, The in 2007 to that in 2010?
Give a very brief answer. 1.04. What is the ratio of the Primary completion rate (% of total enrollments) of Sri Lanka in 2007 to that in 2010?
Provide a succinct answer. 0.97. What is the ratio of the Primary completion rate (% of total enrollments) of Barbados in 2008 to that in 2010?
Keep it short and to the point. 0.97. What is the ratio of the Primary completion rate (% of total enrollments) of Croatia in 2008 to that in 2010?
Provide a short and direct response. 1.06. What is the ratio of the Primary completion rate (% of total enrollments) of Gambia, The in 2008 to that in 2010?
Your response must be concise. 1.08. What is the ratio of the Primary completion rate (% of total enrollments) in Sri Lanka in 2008 to that in 2010?
Give a very brief answer. 0.92. What is the difference between the highest and the second highest Primary completion rate (% of total enrollments) of Barbados?
Provide a short and direct response. 1.58. What is the difference between the highest and the second highest Primary completion rate (% of total enrollments) of Croatia?
Provide a succinct answer. 2.71. What is the difference between the highest and the second highest Primary completion rate (% of total enrollments) of Gambia, The?
Provide a short and direct response. 0.83. What is the difference between the highest and the second highest Primary completion rate (% of total enrollments) in Sri Lanka?
Your answer should be very brief. 5.82. What is the difference between the highest and the lowest Primary completion rate (% of total enrollments) of Barbados?
Keep it short and to the point. 16.88. What is the difference between the highest and the lowest Primary completion rate (% of total enrollments) in Croatia?
Provide a short and direct response. 10.08. What is the difference between the highest and the lowest Primary completion rate (% of total enrollments) in Gambia, The?
Your response must be concise. 10.89. What is the difference between the highest and the lowest Primary completion rate (% of total enrollments) in Sri Lanka?
Provide a short and direct response. 21.62. 